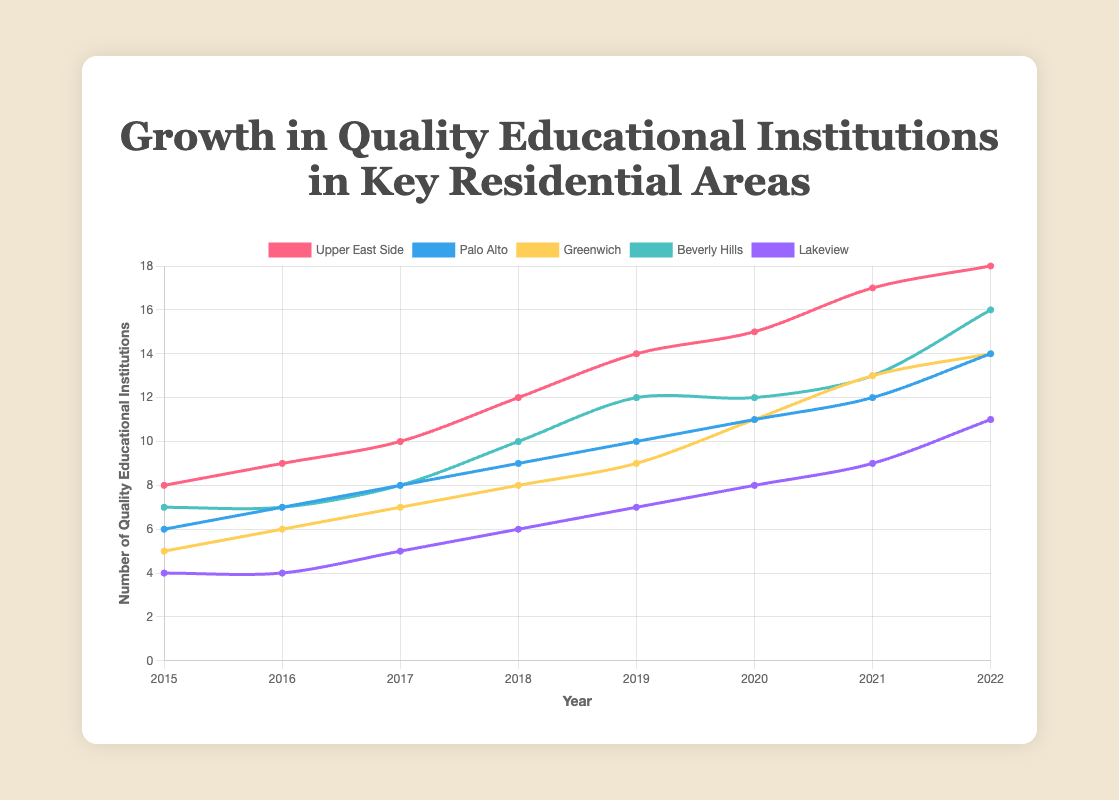What is the total number of schools added across all neighborhoods from 2015 to 2022? To find the total number of schools added, calculate the difference between the number of schools in 2015 and 2022 for each neighborhood, then sum these differences: (18-8) + (14-6) + (14-5) + (16-7) + (11-4) = 10 + 8 + 9 + 9 + 7 = 43
Answer: 43 Which neighborhood had the highest number of schools in 2022? Looking at the data for 2022, the Upper East Side had 18 schools, which is higher than Palo Alto (14), Greenwich (14), Beverly Hills (16), and Lakeview (11)
Answer: Upper East Side Which neighborhood experienced the most rapid growth in the number of schools from 2015 to 2022? Calculate the growth for each neighborhood by subtracting the 2015 number from the 2022 number. Upper East Side: 18-8=10, Palo Alto: 14-6=8, Greenwich: 14-5=9, Beverly Hills: 16-7=9, Lakeview: 11-4=7. The highest growth is 10 schools in Upper East Side
Answer: Upper East Side How many more schools did Beverly Hills have in 2022 compared to 2020? Beverly Hills had 16 schools in 2022 and 12 schools in 2020. The difference is 16 - 12 = 4
Answer: 4 In which year did Upper East Side surpass Greenwich in the number of schools? In 2018, Upper East Side had 12 schools and Greenwich had 8 schools. This is the first year when Upper East Side surpassed Greenwich in the number of schools
Answer: 2018 What is the average number of schools in Palo Alto from 2015 to 2022? To calculate the average, sum all values from 2015 to 2022 and divide by the number of years: (6 + 7 + 8 + 9 + 10 + 11 + 12 + 14) / 8 = 77 / 8 = 9.625
Answer: 9.625 Which neighborhood had the least number of schools in 2017, and how many schools did it have? In 2017, Lakeview had the least number of schools with 5 schools
Answer: Lakeview, 5 What is the combined number of schools for all neighborhoods in 2019? Sum the number of schools for all neighborhoods in the year 2019: 14 (Upper East Side) + 10 (Palo Alto) + 9 (Greenwich) + 12 (Beverly Hills) + 7 (Lakeview) = 52
Answer: 52 Which two neighborhoods had the same number of schools in 2022 and how many? Both Palo Alto and Greenwich had 14 schools in 2022
Answer: Palo Alto and Greenwich, 14 What is the trend in the number of schools in Lakeview from 2015 to 2022? The trend for Lakeview shows a consistent increase: 4 (2015), 4 (2016), 5 (2017), 6 (2018), 7 (2019), 8 (2020), 9 (2021), 11 (2022). Overall, there's an upward trend
Answer: Increasing 